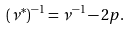Convert formula to latex. <formula><loc_0><loc_0><loc_500><loc_500>( \nu ^ { * } ) ^ { - 1 } = \nu ^ { - 1 } - 2 p .</formula> 